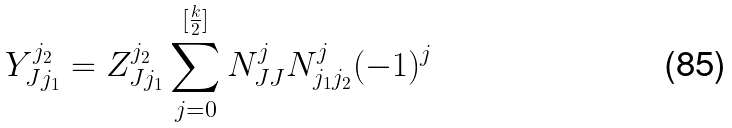Convert formula to latex. <formula><loc_0><loc_0><loc_500><loc_500>Y _ { J j _ { 1 } } ^ { j _ { 2 } } = Z _ { J j _ { 1 } } ^ { j _ { 2 } } \sum _ { j = 0 } ^ { [ \frac { k } { 2 } ] } N _ { J J } ^ { j } N _ { j _ { 1 } j _ { 2 } } ^ { j } ( - 1 ) ^ { j }</formula> 